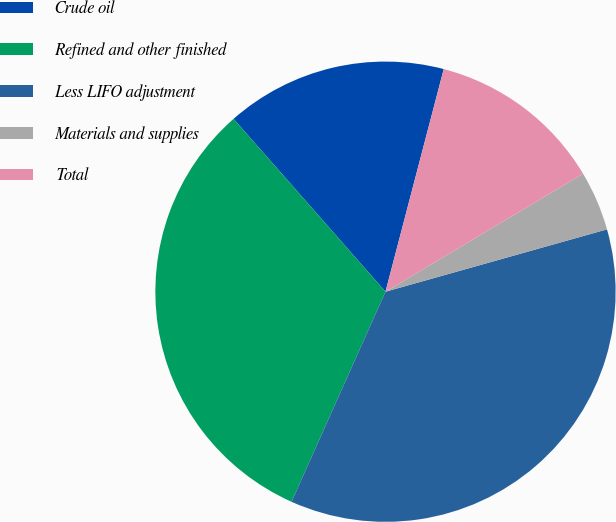<chart> <loc_0><loc_0><loc_500><loc_500><pie_chart><fcel>Crude oil<fcel>Refined and other finished<fcel>Less LIFO adjustment<fcel>Materials and supplies<fcel>Total<nl><fcel>15.55%<fcel>31.83%<fcel>36.06%<fcel>4.2%<fcel>12.36%<nl></chart> 